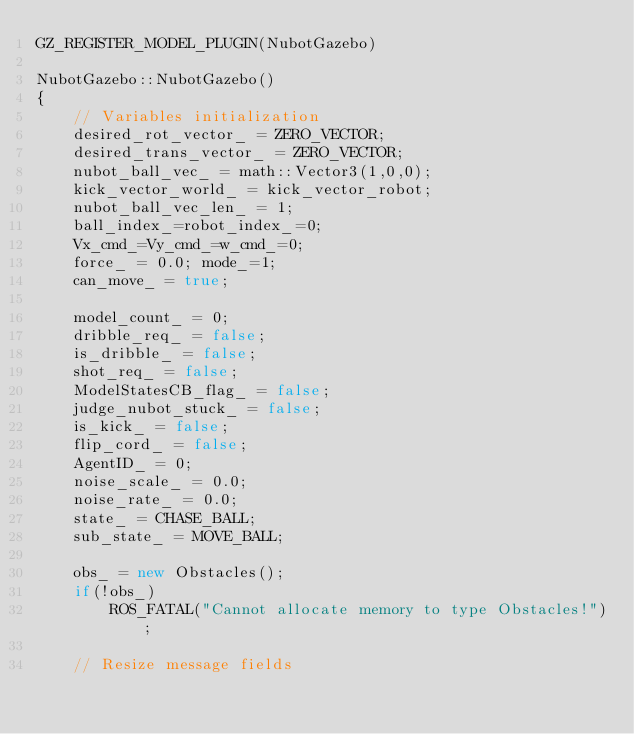<code> <loc_0><loc_0><loc_500><loc_500><_C++_>GZ_REGISTER_MODEL_PLUGIN(NubotGazebo)

NubotGazebo::NubotGazebo()
{
    // Variables initialization
    desired_rot_vector_ = ZERO_VECTOR;
    desired_trans_vector_ = ZERO_VECTOR;
    nubot_ball_vec_ = math::Vector3(1,0,0);
    kick_vector_world_ = kick_vector_robot;
    nubot_ball_vec_len_ = 1;
    ball_index_=robot_index_=0;
    Vx_cmd_=Vy_cmd_=w_cmd_=0;
    force_ = 0.0; mode_=1;
    can_move_ = true;

    model_count_ = 0;
    dribble_req_ = false;
    is_dribble_ = false;
    shot_req_ = false;
    ModelStatesCB_flag_ = false;
    judge_nubot_stuck_ = false;
    is_kick_ = false;
    flip_cord_ = false;
    AgentID_ = 0;
    noise_scale_ = 0.0;
    noise_rate_ = 0.0;
    state_ = CHASE_BALL;
    sub_state_ = MOVE_BALL;

    obs_ = new Obstacles();
    if(!obs_)
        ROS_FATAL("Cannot allocate memory to type Obstacles!");

    // Resize message fields</code> 